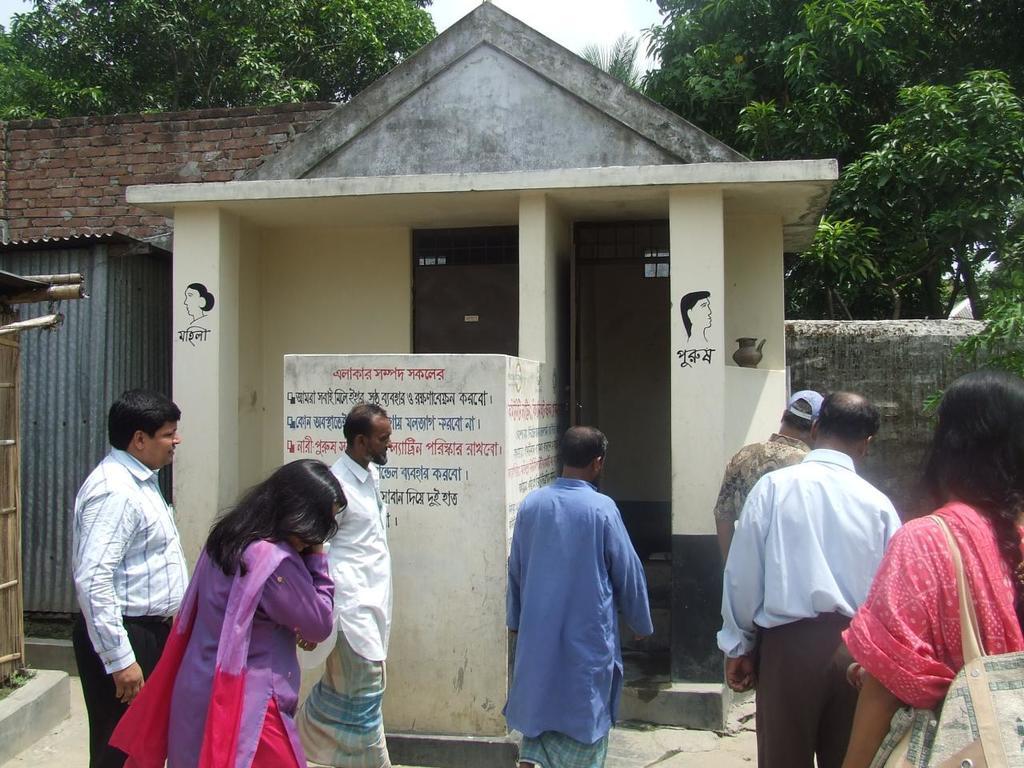In one or two sentences, can you explain what this image depicts? In this picture there are people in front of a public toilet and there are sheds on the left side of the image, there are trees at the top side of the image. 